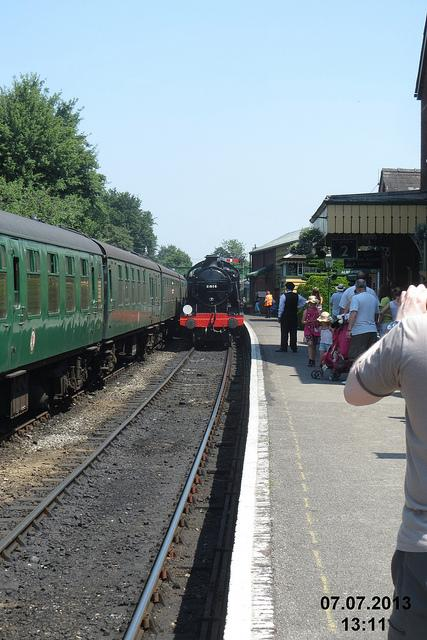How many days after the Independence Day was this picture taken?

Choices:
A) three
B) one
C) two
D) seven three 